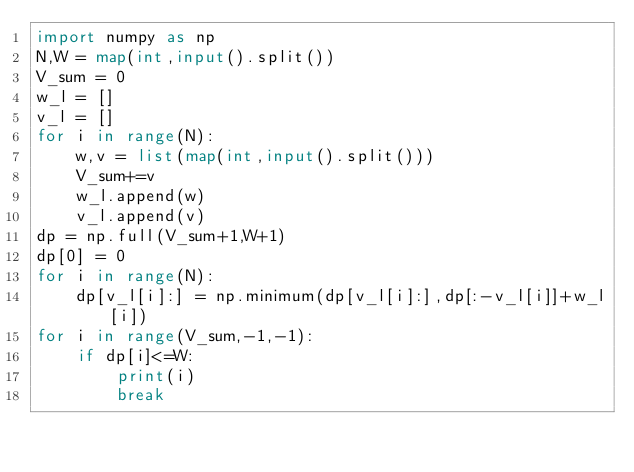Convert code to text. <code><loc_0><loc_0><loc_500><loc_500><_Python_>import numpy as np
N,W = map(int,input().split())
V_sum = 0
w_l = []
v_l = []
for i in range(N):
    w,v = list(map(int,input().split()))
    V_sum+=v
    w_l.append(w)
    v_l.append(v)
dp = np.full(V_sum+1,W+1)
dp[0] = 0
for i in range(N):
    dp[v_l[i]:] = np.minimum(dp[v_l[i]:],dp[:-v_l[i]]+w_l[i])
for i in range(V_sum,-1,-1):
    if dp[i]<=W:
        print(i)
        break
    
    </code> 